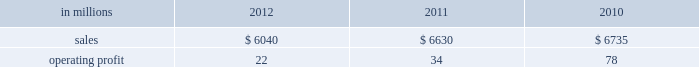Foodservice sales volumes increased in 2012 compared with 2011 .
Average sales margins were higher reflecting the realization of sales price increases for the pass-through of earlier cost increases .
Raw material costs for board and resins were lower .
Operating costs and distribution costs were both higher .
The u.s .
Shorewood business was sold december 31 , 2011 and the non-u.s .
Business was sold in january looking ahead to the first quarter of 2013 , coated paperboard sales volumes are expected to increase slightly from the fourth quarter of 2012 .
Average sales price realizations are expected to be slightly lower , but margins should benefit from a more favorable product mix .
Input costs are expected to be higher for energy and wood .
No planned main- tenance outages are scheduled in the first quarter .
In january 2013 the company announced the perma- nent shutdown of a coated paperboard machine at the augusta mill with an annual capacity of 140000 tons .
Foodservice sales volumes are expected to increase .
Average sales margins are expected to decrease due to the realization of sales price decreases effective with our january contract open- ers .
Input costs for board and resin are expected to be lower and operating costs are also expected to decrease .
European consumer packaging net sales in 2012 were $ 380 million compared with $ 375 million in 2011 and $ 345 million in 2010 .
Operating profits in 2012 were $ 99 million compared with $ 93 million in 2011 and $ 76 million in 2010 .
Sales volumes in 2012 increased from 2011 .
Average sales price realizations were higher in russian markets , but were lower in european markets .
Input costs decreased , primarily for wood , and planned maintenance downtime costs were lower in 2012 than in 2011 .
Looking forward to the first quarter of 2013 , sales volumes are expected to decrease in both europe and russia .
Average sales price realizations are expected to be higher in russia , but be more than offset by decreases in europe .
Input costs are expected to increase for wood and chemicals .
No maintenance outages are scheduled for the first quarter .
Asian consumer packaging net sales were $ 830 million in 2012 compared with $ 855 million in 2011 and $ 705 million in 2010 .
Operating profits in 2012 were $ 4 million compared with $ 35 million in 2011 and $ 34 million in 2010 .
Sales volumes increased in 2012 compared with 2011 partially due to the start-up of a new coated paperboard machine .
Average sales price realizations were significantly lower , but were partially offset by lower input costs for purchased pulp .
Start-up costs for a new coated paperboard machine adversely impacted operating profits in 2012 .
In the first quarter of 2013 , sales volumes are expected to increase slightly .
Average sales price realizations for folding carton board and bristols board are expected to be lower reflecting increased competitive pressures and seasonally weaker market demand .
Input costs should be higher for pulp and chemicals .
However , costs related to the ramp-up of the new coated paperboard machine should be lower .
Distribution xpedx , our distribution business , is one of north america 2019s leading business-to-business distributors to manufacturers , facility managers and printers , providing customized solutions that are designed to improve efficiency , reduce costs and deliver results .
Customer demand is generally sensitive to changes in economic conditions and consumer behavior , along with segment specific activity including corpo- rate advertising and promotional spending , government spending and domestic manufacturing activity .
Distribution 2019s margins are relatively stable across an economic cycle .
Providing customers with the best choice for value in both products and supply chain services is a key competitive factor .
Addition- ally , efficient customer service , cost-effective logis- tics and focused working capital management are key factors in this segment 2019s profitability .
Distribution .
Distr ibut ion 2019s 2012 annual sales decreased 9% ( 9 % ) from 2011 , and decreased 10% ( 10 % ) from 2010 .
Operating profits in 2012 were $ 22 million ( $ 71 million exclud- ing reorganization costs ) compared with $ 34 million ( $ 86 million excluding reorganization costs ) in 2011 and $ 78 million in 2010 .
Annual sales of printing papers and graphic arts supplies and equipment totaled $ 3.5 billion in 2012 compared with $ 4.0 billion in 2011 and $ 4.2 billion in 2010 , reflecting declining demand and the exiting of unprofitable businesses .
Trade margins as a percent of sales for printing papers were relatively even with both 2011 and 2010 .
Revenue from packaging prod- ucts was flat at $ 1.6 billion in both 2012 and 2011 and up slightly compared to $ 1.5 billion in 2010 .
Pack- aging margins increased in 2012 from both 2011 and 2010 , reflecting the successful execution of strategic sourcing initiatives .
Facility supplies annual revenue was $ 0.9 billion in 2012 , down compared to $ 1.0 bil- lion in 2011 and 2010 .
Operating profits in 2012 included $ 49 million of reorganization costs for severance , professional services and asset write-downs compared with $ 52 .
What percent of distribution sales where attributable to printing papers and graphic arts supplies and equipment in 2011? 
Computations: ((4 * 1000) / 6630)
Answer: 0.60332. Foodservice sales volumes increased in 2012 compared with 2011 .
Average sales margins were higher reflecting the realization of sales price increases for the pass-through of earlier cost increases .
Raw material costs for board and resins were lower .
Operating costs and distribution costs were both higher .
The u.s .
Shorewood business was sold december 31 , 2011 and the non-u.s .
Business was sold in january looking ahead to the first quarter of 2013 , coated paperboard sales volumes are expected to increase slightly from the fourth quarter of 2012 .
Average sales price realizations are expected to be slightly lower , but margins should benefit from a more favorable product mix .
Input costs are expected to be higher for energy and wood .
No planned main- tenance outages are scheduled in the first quarter .
In january 2013 the company announced the perma- nent shutdown of a coated paperboard machine at the augusta mill with an annual capacity of 140000 tons .
Foodservice sales volumes are expected to increase .
Average sales margins are expected to decrease due to the realization of sales price decreases effective with our january contract open- ers .
Input costs for board and resin are expected to be lower and operating costs are also expected to decrease .
European consumer packaging net sales in 2012 were $ 380 million compared with $ 375 million in 2011 and $ 345 million in 2010 .
Operating profits in 2012 were $ 99 million compared with $ 93 million in 2011 and $ 76 million in 2010 .
Sales volumes in 2012 increased from 2011 .
Average sales price realizations were higher in russian markets , but were lower in european markets .
Input costs decreased , primarily for wood , and planned maintenance downtime costs were lower in 2012 than in 2011 .
Looking forward to the first quarter of 2013 , sales volumes are expected to decrease in both europe and russia .
Average sales price realizations are expected to be higher in russia , but be more than offset by decreases in europe .
Input costs are expected to increase for wood and chemicals .
No maintenance outages are scheduled for the first quarter .
Asian consumer packaging net sales were $ 830 million in 2012 compared with $ 855 million in 2011 and $ 705 million in 2010 .
Operating profits in 2012 were $ 4 million compared with $ 35 million in 2011 and $ 34 million in 2010 .
Sales volumes increased in 2012 compared with 2011 partially due to the start-up of a new coated paperboard machine .
Average sales price realizations were significantly lower , but were partially offset by lower input costs for purchased pulp .
Start-up costs for a new coated paperboard machine adversely impacted operating profits in 2012 .
In the first quarter of 2013 , sales volumes are expected to increase slightly .
Average sales price realizations for folding carton board and bristols board are expected to be lower reflecting increased competitive pressures and seasonally weaker market demand .
Input costs should be higher for pulp and chemicals .
However , costs related to the ramp-up of the new coated paperboard machine should be lower .
Distribution xpedx , our distribution business , is one of north america 2019s leading business-to-business distributors to manufacturers , facility managers and printers , providing customized solutions that are designed to improve efficiency , reduce costs and deliver results .
Customer demand is generally sensitive to changes in economic conditions and consumer behavior , along with segment specific activity including corpo- rate advertising and promotional spending , government spending and domestic manufacturing activity .
Distribution 2019s margins are relatively stable across an economic cycle .
Providing customers with the best choice for value in both products and supply chain services is a key competitive factor .
Addition- ally , efficient customer service , cost-effective logis- tics and focused working capital management are key factors in this segment 2019s profitability .
Distribution .
Distr ibut ion 2019s 2012 annual sales decreased 9% ( 9 % ) from 2011 , and decreased 10% ( 10 % ) from 2010 .
Operating profits in 2012 were $ 22 million ( $ 71 million exclud- ing reorganization costs ) compared with $ 34 million ( $ 86 million excluding reorganization costs ) in 2011 and $ 78 million in 2010 .
Annual sales of printing papers and graphic arts supplies and equipment totaled $ 3.5 billion in 2012 compared with $ 4.0 billion in 2011 and $ 4.2 billion in 2010 , reflecting declining demand and the exiting of unprofitable businesses .
Trade margins as a percent of sales for printing papers were relatively even with both 2011 and 2010 .
Revenue from packaging prod- ucts was flat at $ 1.6 billion in both 2012 and 2011 and up slightly compared to $ 1.5 billion in 2010 .
Pack- aging margins increased in 2012 from both 2011 and 2010 , reflecting the successful execution of strategic sourcing initiatives .
Facility supplies annual revenue was $ 0.9 billion in 2012 , down compared to $ 1.0 bil- lion in 2011 and 2010 .
Operating profits in 2012 included $ 49 million of reorganization costs for severance , professional services and asset write-downs compared with $ 52 .
What was the average annual european consumer packaging net sales from 2010 to 2012 in millions? 
Computations: ((((380 + 375) + 345) + 3) / 2)
Answer: 551.5. 